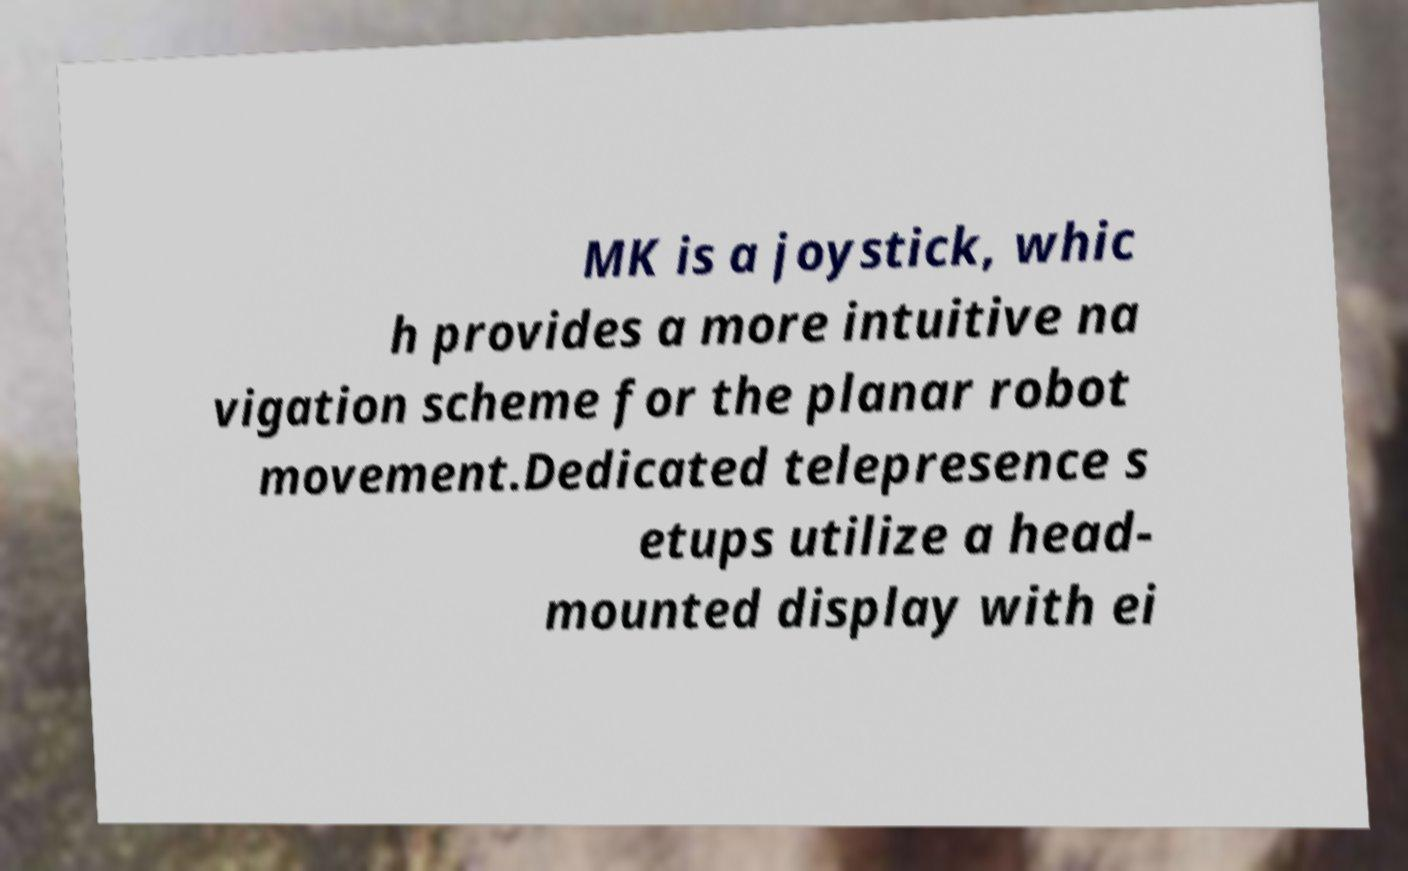There's text embedded in this image that I need extracted. Can you transcribe it verbatim? MK is a joystick, whic h provides a more intuitive na vigation scheme for the planar robot movement.Dedicated telepresence s etups utilize a head- mounted display with ei 